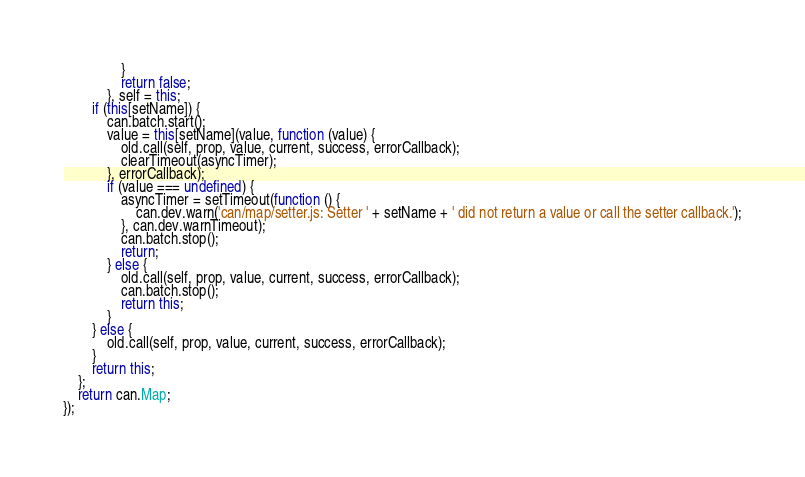<code> <loc_0><loc_0><loc_500><loc_500><_JavaScript_>                }
                return false;
            }, self = this;
        if (this[setName]) {
            can.batch.start();
            value = this[setName](value, function (value) {
                old.call(self, prop, value, current, success, errorCallback);
                clearTimeout(asyncTimer);
            }, errorCallback);
            if (value === undefined) {
                asyncTimer = setTimeout(function () {
                    can.dev.warn('can/map/setter.js: Setter ' + setName + ' did not return a value or call the setter callback.');
                }, can.dev.warnTimeout);
                can.batch.stop();
                return;
            } else {
                old.call(self, prop, value, current, success, errorCallback);
                can.batch.stop();
                return this;
            }
        } else {
            old.call(self, prop, value, current, success, errorCallback);
        }
        return this;
    };
    return can.Map;
});</code> 